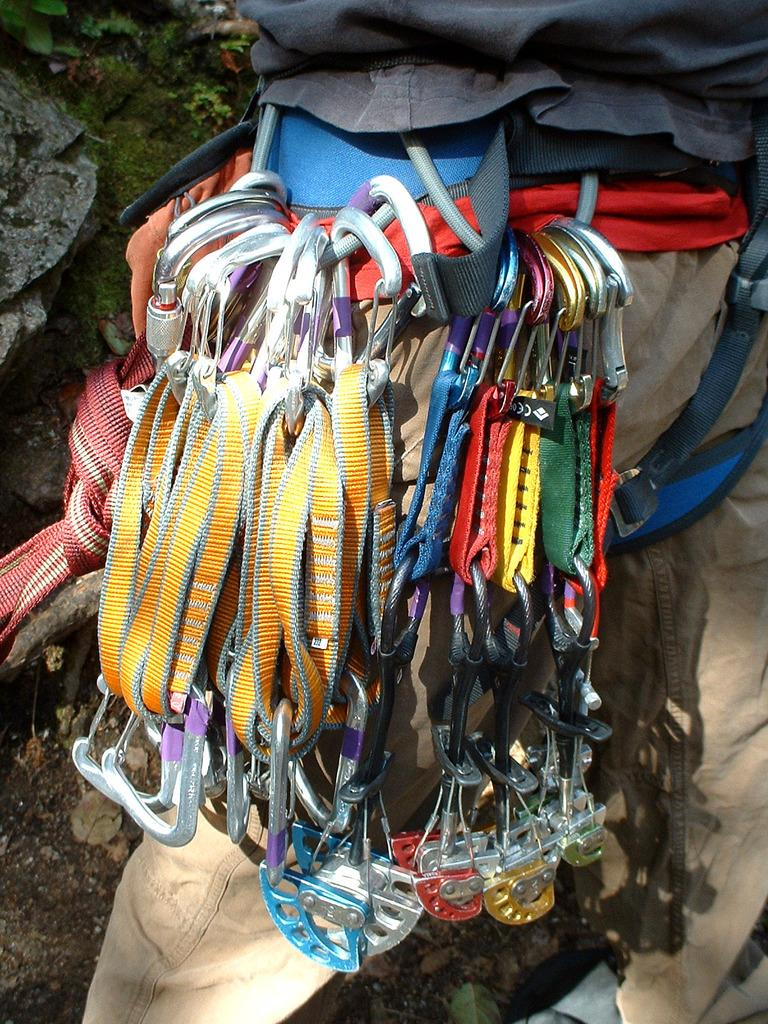What is the main subject of the image? There is a person standing on the land in the image. What is the person wearing that is mentioned in the facts? The person is wearing a belt with hooks. What can be seen on the land besides the person? There are plants and rocks on the land in the image. What type of pail is being used to copy the ground in the image? There is no pail or copying activity present in the image; it features a person standing on the land with plants and rocks. 